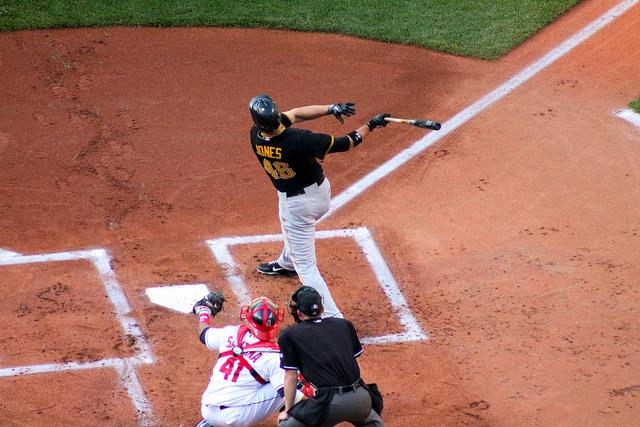What will the standing player do next?

Choices:
A) sit
B) squat
C) run
D) hide run 